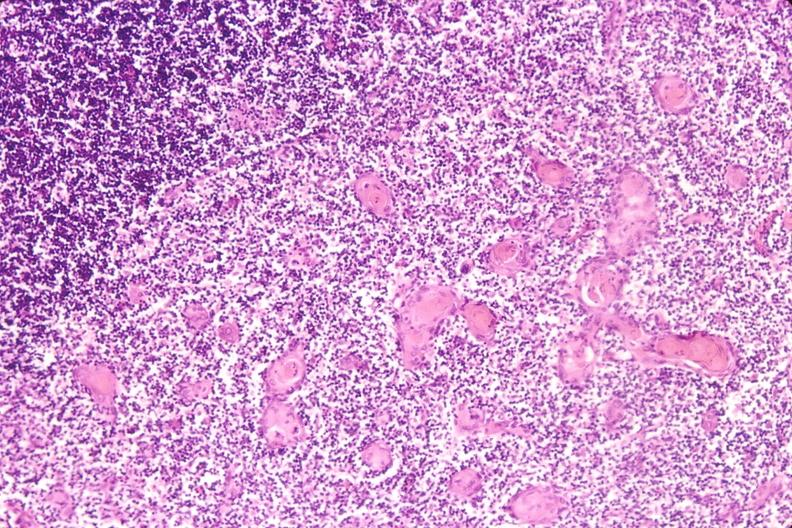does this image show thymus?
Answer the question using a single word or phrase. Yes 